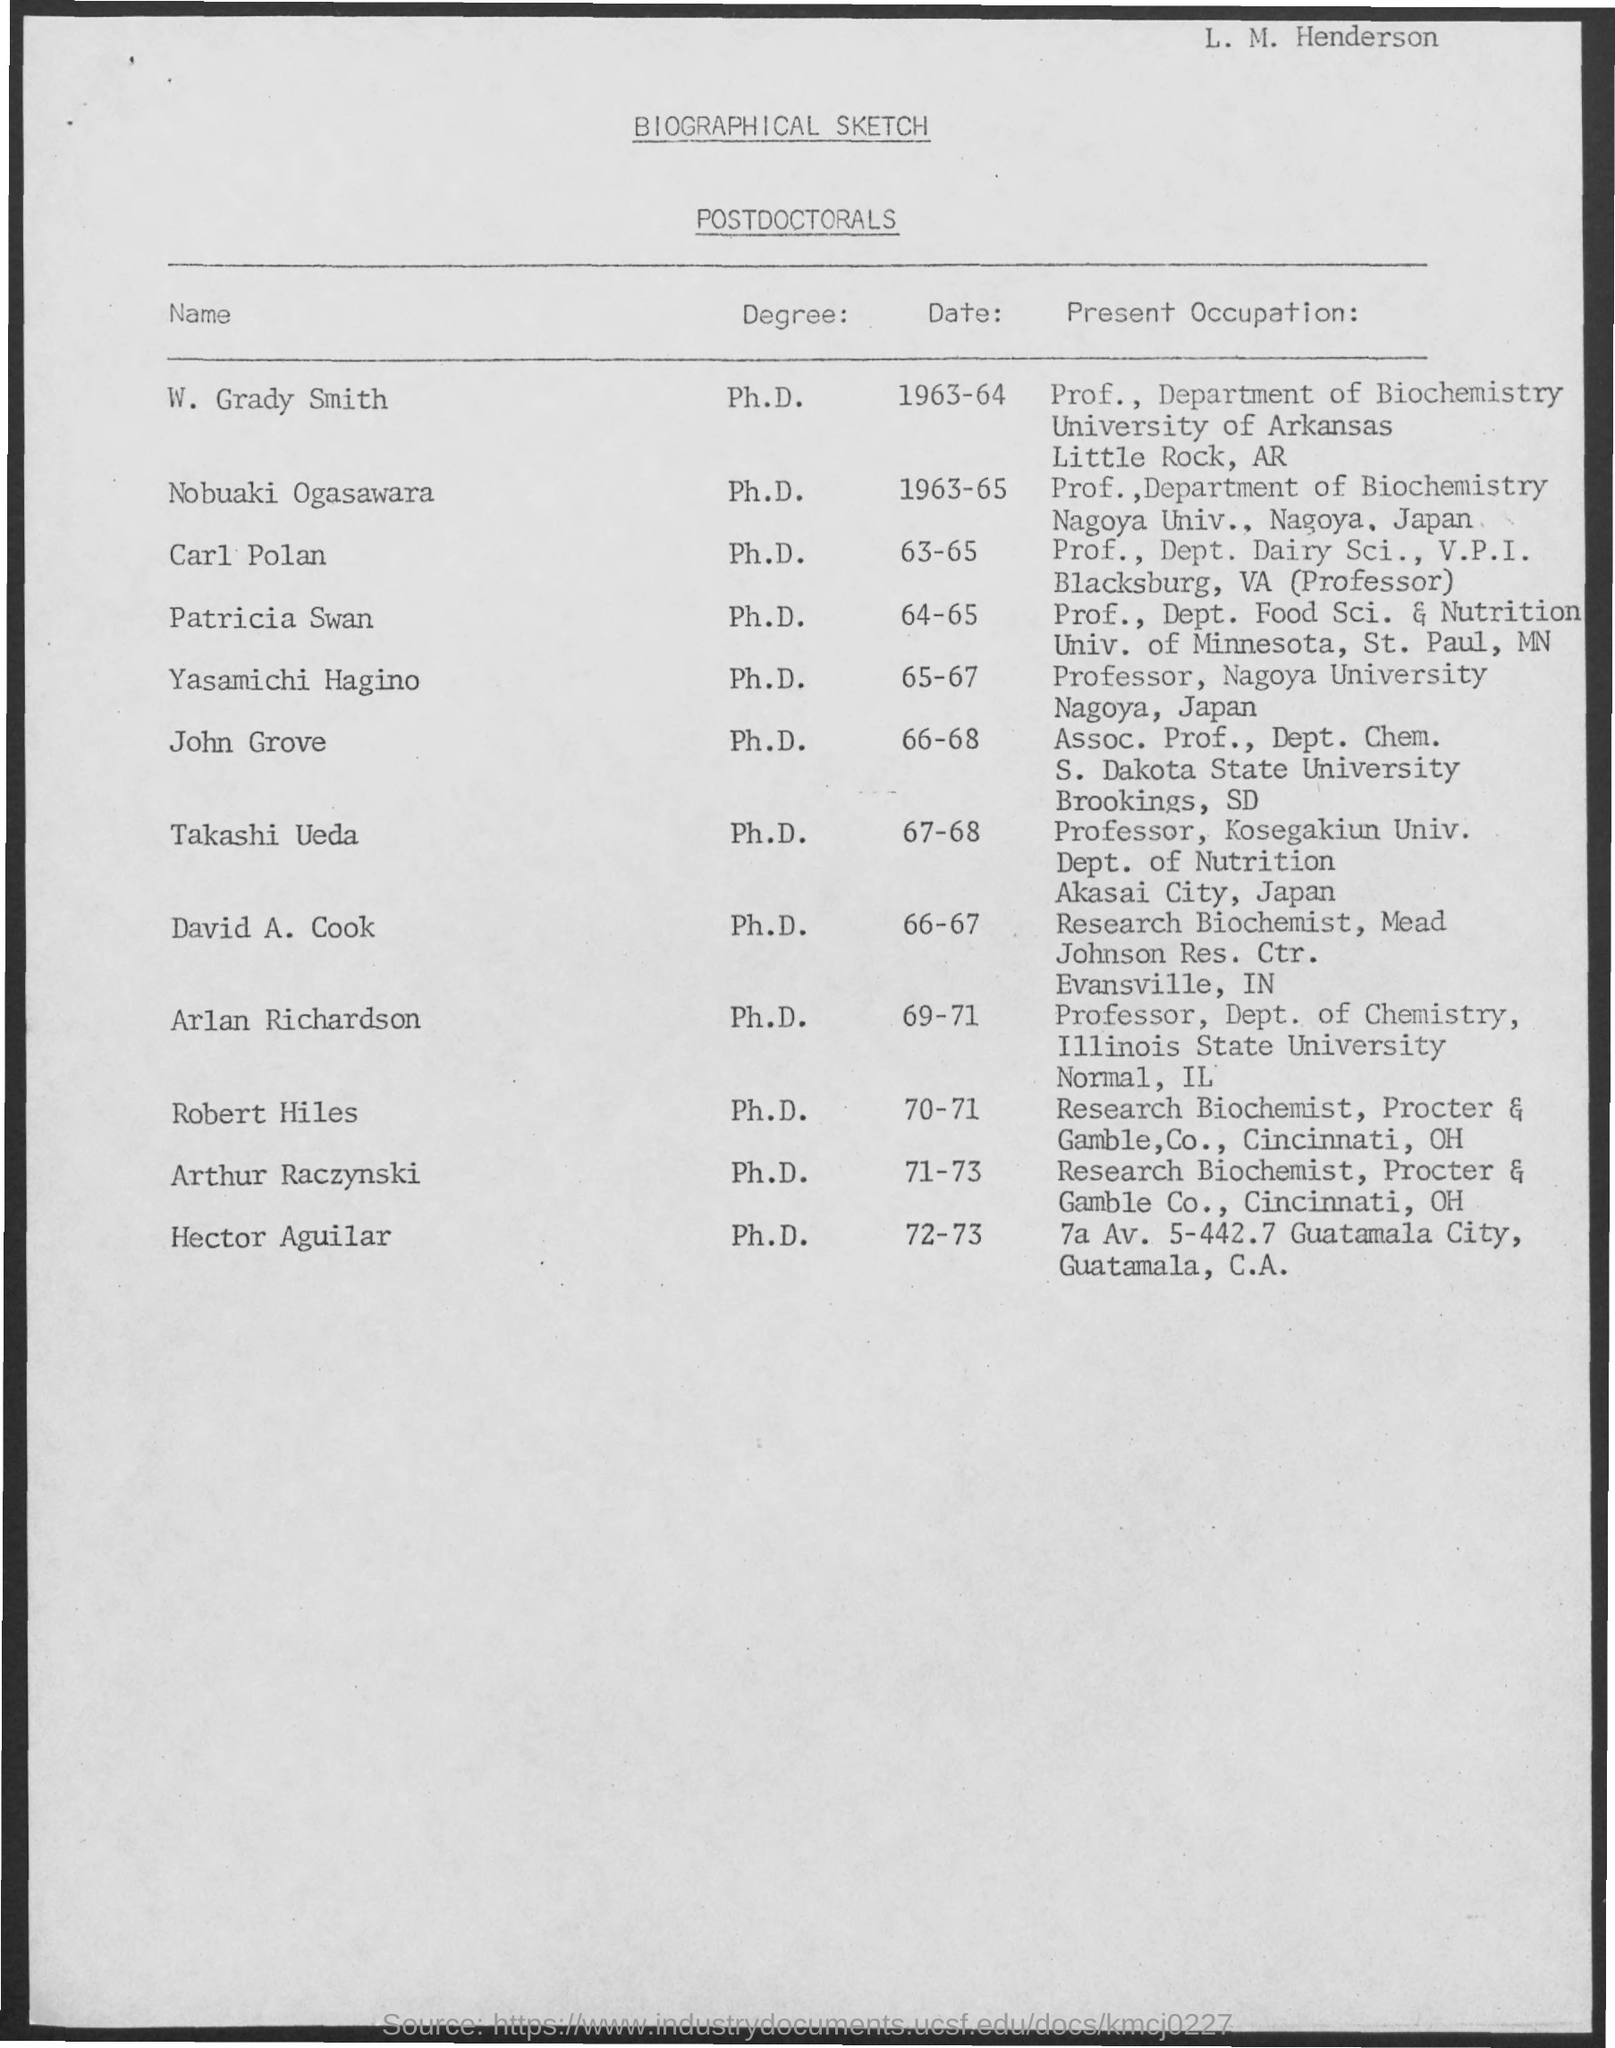What is the Title of the document?
Give a very brief answer. BIOGRAPHICAL SKETCH. What is the Degree for W. Grady Smith?
Provide a short and direct response. Ph.D. What is the Degree for Nobuaki Ogasawara?
Your response must be concise. Ph.D. What is the Degree for Carl Polan?
Offer a very short reply. Ph.D. What is the Degree for Patricia Swan?
Offer a terse response. Ph.D. What is the Degree for John Grove?
Your response must be concise. Ph.D. 